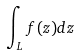Convert formula to latex. <formula><loc_0><loc_0><loc_500><loc_500>\int _ { L } f ( z ) d z</formula> 